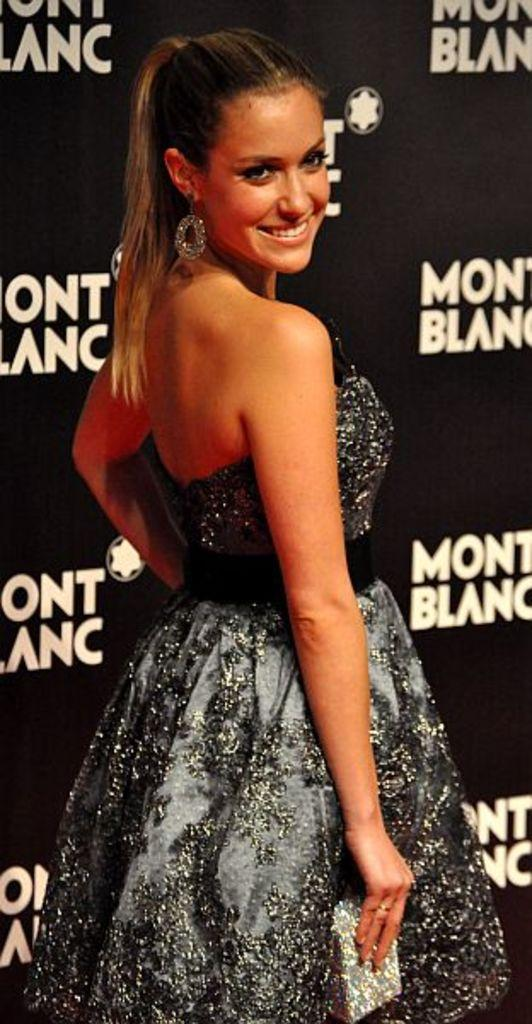What is the main subject of the image? The main subject of the image is a woman. What is the woman doing in the image? The woman is holding an object and smiling. What can be seen in the image besides the woman? There is text visible in the image, and there are a few things on a black object. What type of coal is the woman using to write on the black object in the image? There is no coal present in the image, and the woman is not writing on the black object. Can you tell me how many guns are visible in the image? There are no guns visible in the image. 